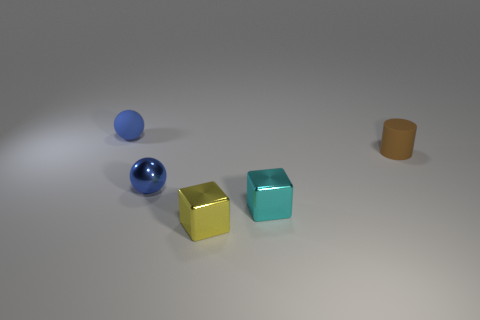Add 2 small brown cylinders. How many objects exist? 7 Subtract all cylinders. How many objects are left? 4 Subtract all matte cubes. Subtract all spheres. How many objects are left? 3 Add 3 brown matte objects. How many brown matte objects are left? 4 Add 5 big blue shiny balls. How many big blue shiny balls exist? 5 Subtract 1 brown cylinders. How many objects are left? 4 